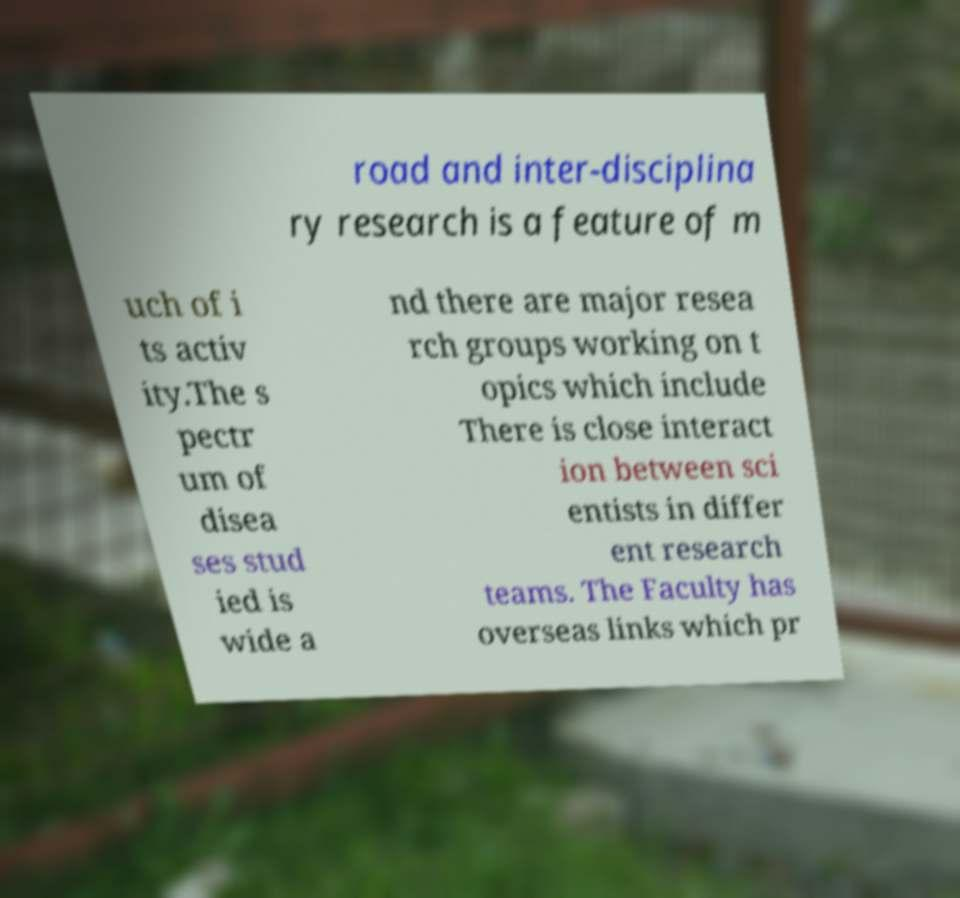I need the written content from this picture converted into text. Can you do that? road and inter-disciplina ry research is a feature of m uch of i ts activ ity.The s pectr um of disea ses stud ied is wide a nd there are major resea rch groups working on t opics which include There is close interact ion between sci entists in differ ent research teams. The Faculty has overseas links which pr 